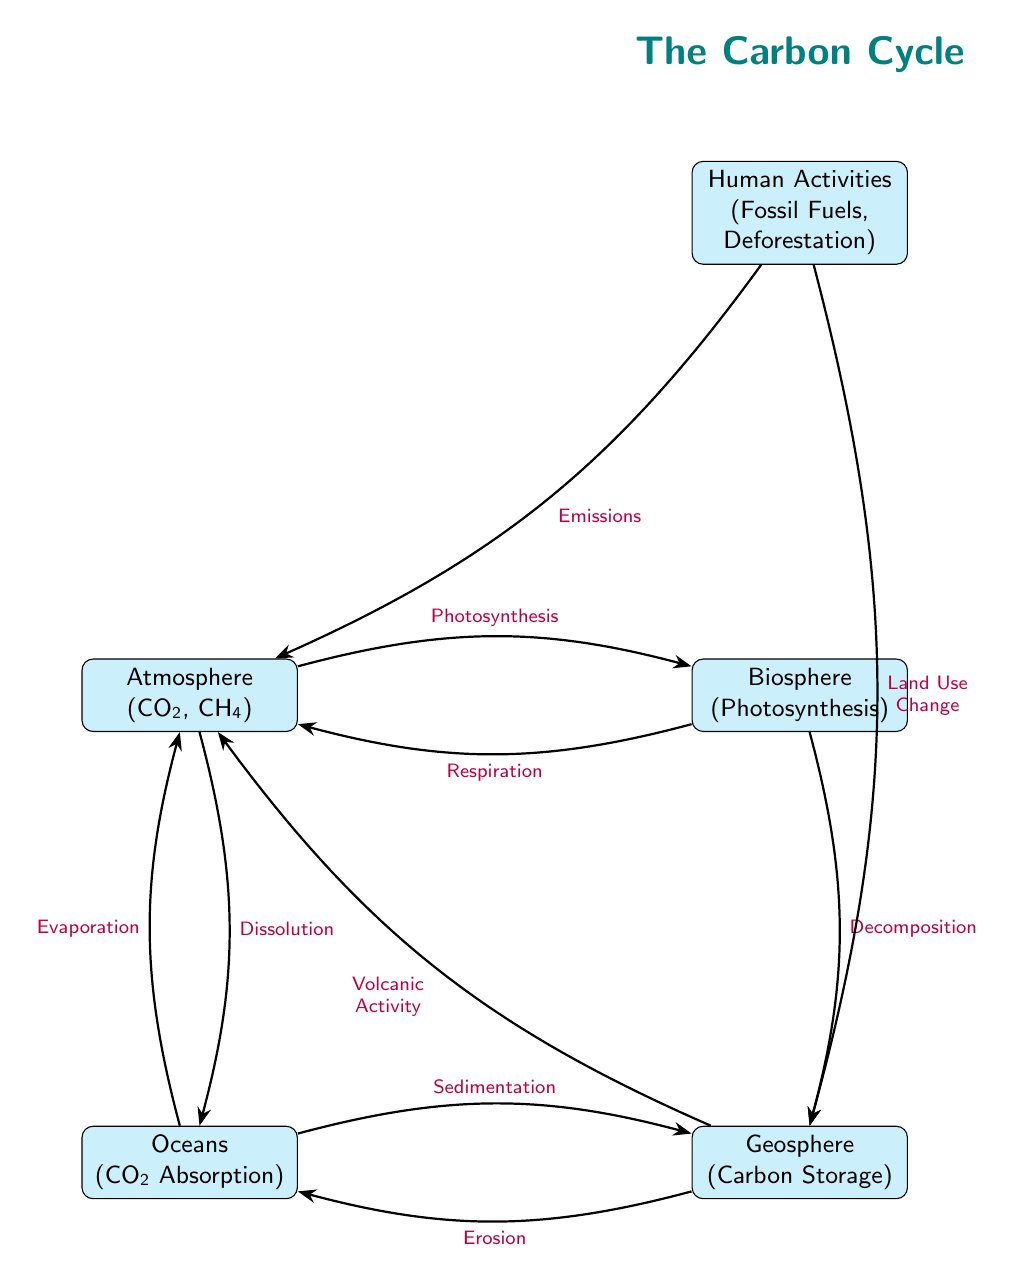What is the top node in the diagram? The top node in the diagram indicates the starting point of the carbon cycle and features "Human Activities".
Answer: Human Activities How many nodes are present in the diagram? Counting all the boxes in the diagram—Atmosphere, Biosphere, Oceans, Geosphere, and Human Activities—there are a total of five nodes.
Answer: 5 Which process connects the atmosphere to the biosphere? The arrow labeled "Photosynthesis" indicates the process that connects the atmosphere to the biosphere, as it shows the movement of carbon from CO₂ in the atmosphere to plants in the biosphere.
Answer: Photosynthesis What flows from the geosphere to the atmosphere? The process labeled "Volcanic Activity" illustrates the flow of carbon from the geosphere back into the atmosphere.
Answer: Volcanic Activity What happens to carbon in the oceans according to the diagram? The diagram shows "Dissolution" as the process by which carbon dioxide from the atmosphere enters the oceans, indicating that it absorbs CO₂.
Answer: Dissolution Which component is responsible for carbon emissions into the atmosphere? The diagram clearly shows that "Human Activities" are labeled with "Emissions", indicating that human actions contribute carbon to the atmosphere.
Answer: Emissions What process occurs from the biosphere to the geosphere? The labeled process "Decomposition" illustrates how carbon moves from living organisms in the biosphere into the geosphere, where it is stored.
Answer: Decomposition Which process leads to carbon storage in the geosphere? The "Sedimentation" process, as illustrated in the diagram, describes how carbon from the oceans is eventually stored in the geosphere.
Answer: Sedimentation What connects the oceans to the atmosphere? The labeled process "Evaporation" shows the cycle where carbon in the oceans returns to the atmosphere.
Answer: Evaporation 